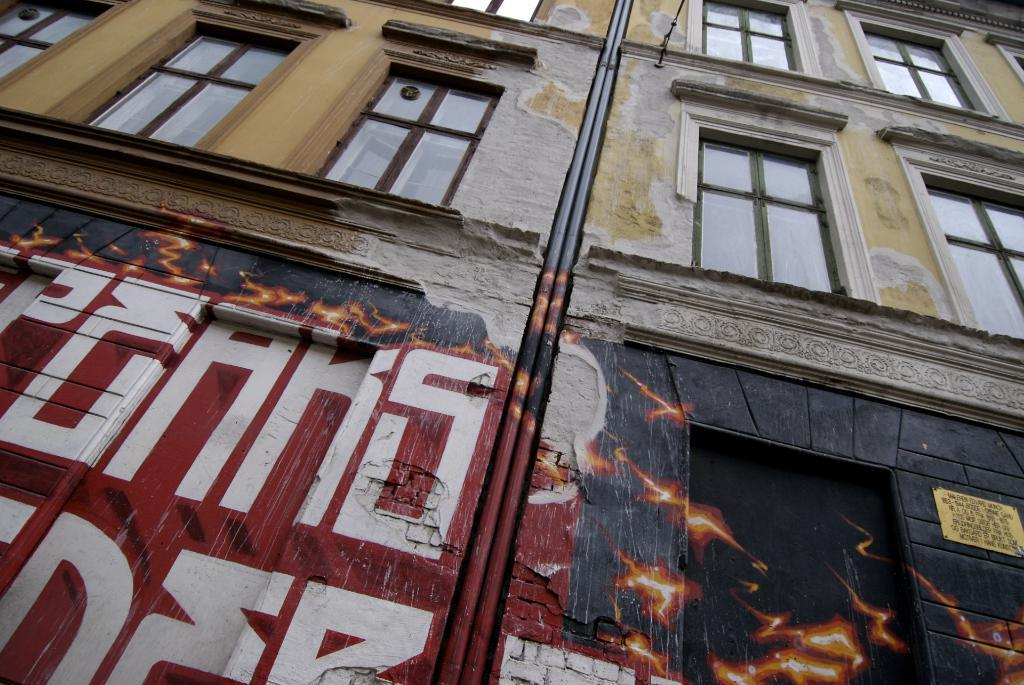What is the main structure in the image? There is a building in the image. What feature can be seen on the building? The building has windows. Is there any artwork visible on the building? Yes, there is a painting on the walls in the front of the building. How many apples are being held by the queen in the image? There is no queen or apples present in the image. Are there any snakes visible in the image? There are no snakes visible in the image. 